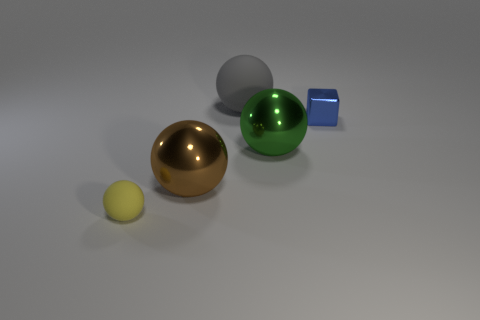The tiny matte sphere is what color?
Provide a succinct answer. Yellow. What number of metal things are yellow balls or brown spheres?
Ensure brevity in your answer.  1. Is there anything else that is the same material as the tiny block?
Keep it short and to the point. Yes. What is the size of the object right of the ball to the right of the matte ball that is behind the small metallic object?
Your response must be concise. Small. What size is the sphere that is both to the right of the big brown ball and in front of the tiny blue metallic object?
Ensure brevity in your answer.  Large. Is the color of the small object that is left of the small metal cube the same as the object that is behind the tiny metal thing?
Keep it short and to the point. No. What number of matte objects are behind the small ball?
Keep it short and to the point. 1. There is a shiny sphere on the left side of the matte object that is behind the small matte sphere; are there any small things that are to the right of it?
Your answer should be compact. Yes. How many yellow rubber things are the same size as the yellow rubber sphere?
Keep it short and to the point. 0. What is the material of the green sphere behind the tiny thing that is on the left side of the blue thing?
Your answer should be very brief. Metal. 